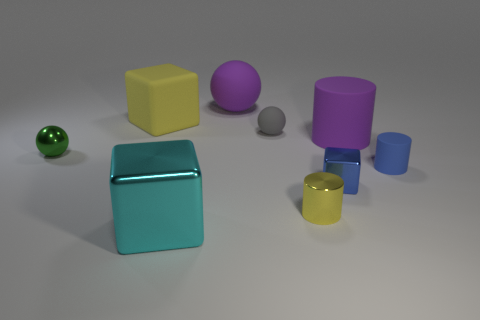What shape is the tiny gray matte thing?
Your response must be concise. Sphere. There is a blue metallic thing on the right side of the tiny object that is behind the green thing; what size is it?
Ensure brevity in your answer.  Small. Are there the same number of yellow metal cylinders that are on the left side of the big cyan metal thing and small things that are to the left of the small blue cylinder?
Your answer should be very brief. No. There is a thing that is on the left side of the big cyan shiny block and behind the green metal ball; what is its material?
Offer a terse response. Rubber. Does the blue shiny cube have the same size as the ball that is behind the large yellow matte thing?
Your answer should be very brief. No. What number of other objects are there of the same color as the large matte block?
Keep it short and to the point. 1. Are there more things that are behind the big yellow rubber thing than big blue matte cylinders?
Make the answer very short. Yes. The rubber cylinder that is on the left side of the blue matte thing behind the small blue object that is on the left side of the small rubber cylinder is what color?
Make the answer very short. Purple. Is the material of the tiny blue cube the same as the large cyan thing?
Offer a terse response. Yes. Are there any rubber cylinders that have the same size as the blue metal cube?
Ensure brevity in your answer.  Yes. 